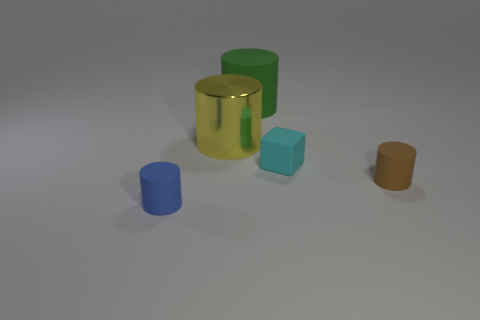Add 1 small things. How many objects exist? 6 Subtract all blocks. How many objects are left? 4 Subtract 0 purple cylinders. How many objects are left? 5 Subtract all brown cylinders. Subtract all blue cylinders. How many objects are left? 3 Add 3 large matte objects. How many large matte objects are left? 4 Add 4 big purple matte cylinders. How many big purple matte cylinders exist? 4 